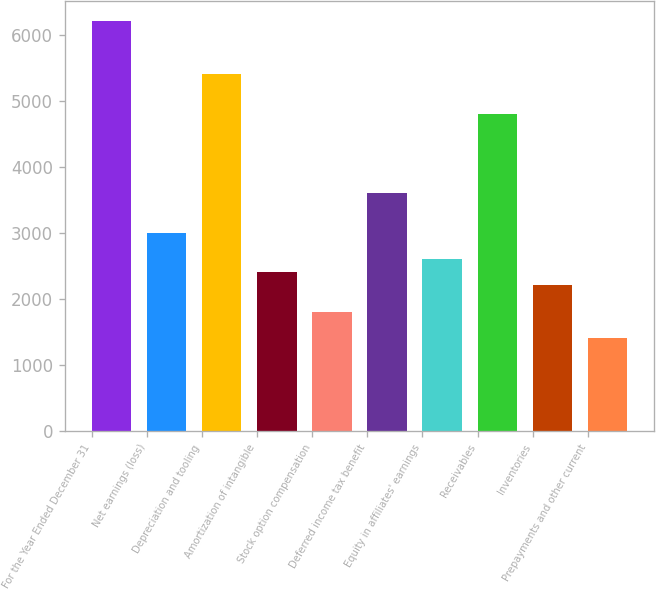Convert chart to OTSL. <chart><loc_0><loc_0><loc_500><loc_500><bar_chart><fcel>For the Year Ended December 31<fcel>Net earnings (loss)<fcel>Depreciation and tooling<fcel>Amortization of intangible<fcel>Stock option compensation<fcel>Deferred income tax benefit<fcel>Equity in affiliates' earnings<fcel>Receivables<fcel>Inventories<fcel>Prepayments and other current<nl><fcel>6214.3<fcel>3009.5<fcel>5413.1<fcel>2408.6<fcel>1807.7<fcel>3610.4<fcel>2608.9<fcel>4812.2<fcel>2208.3<fcel>1407.1<nl></chart> 